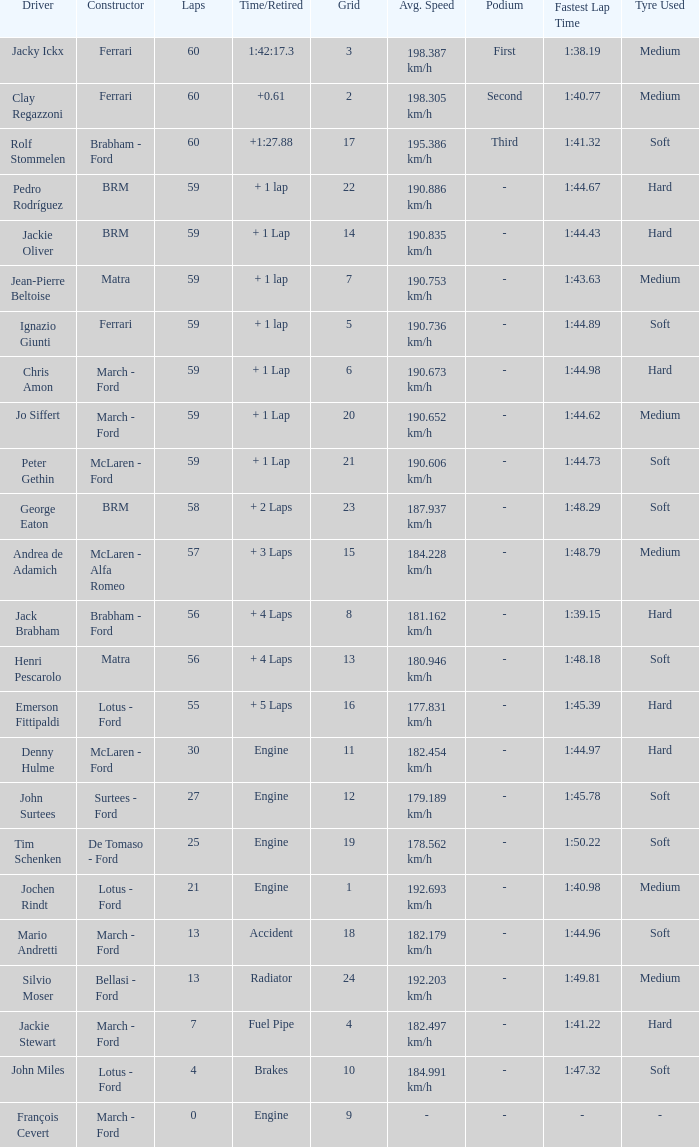I want the driver for grid of 9 François Cevert. 